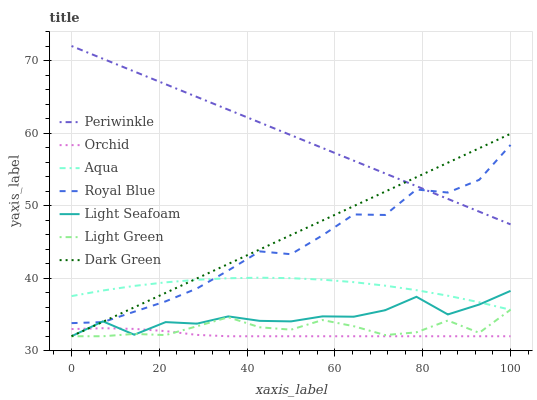Does Orchid have the minimum area under the curve?
Answer yes or no. Yes. Does Periwinkle have the maximum area under the curve?
Answer yes or no. Yes. Does Dark Green have the minimum area under the curve?
Answer yes or no. No. Does Dark Green have the maximum area under the curve?
Answer yes or no. No. Is Periwinkle the smoothest?
Answer yes or no. Yes. Is Light Seafoam the roughest?
Answer yes or no. Yes. Is Dark Green the smoothest?
Answer yes or no. No. Is Dark Green the roughest?
Answer yes or no. No. Does Dark Green have the lowest value?
Answer yes or no. Yes. Does Royal Blue have the lowest value?
Answer yes or no. No. Does Periwinkle have the highest value?
Answer yes or no. Yes. Does Dark Green have the highest value?
Answer yes or no. No. Is Orchid less than Periwinkle?
Answer yes or no. Yes. Is Aqua greater than Orchid?
Answer yes or no. Yes. Does Orchid intersect Light Seafoam?
Answer yes or no. Yes. Is Orchid less than Light Seafoam?
Answer yes or no. No. Is Orchid greater than Light Seafoam?
Answer yes or no. No. Does Orchid intersect Periwinkle?
Answer yes or no. No. 